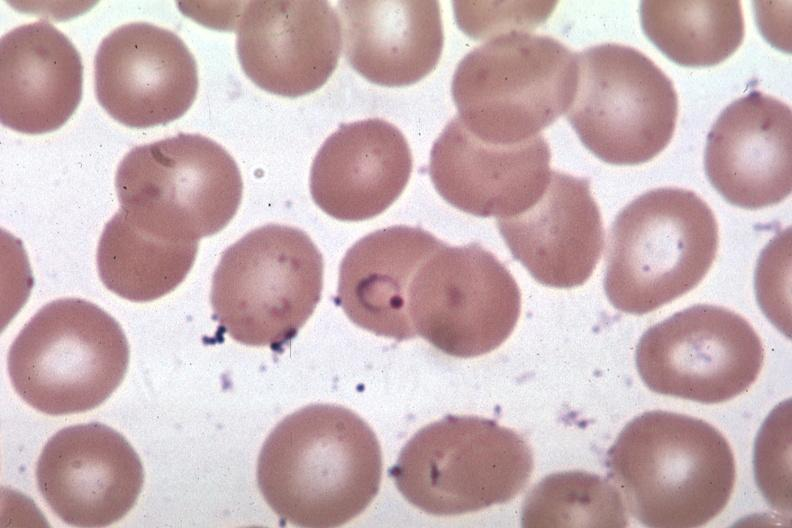s this therapy present?
Answer the question using a single word or phrase. No 